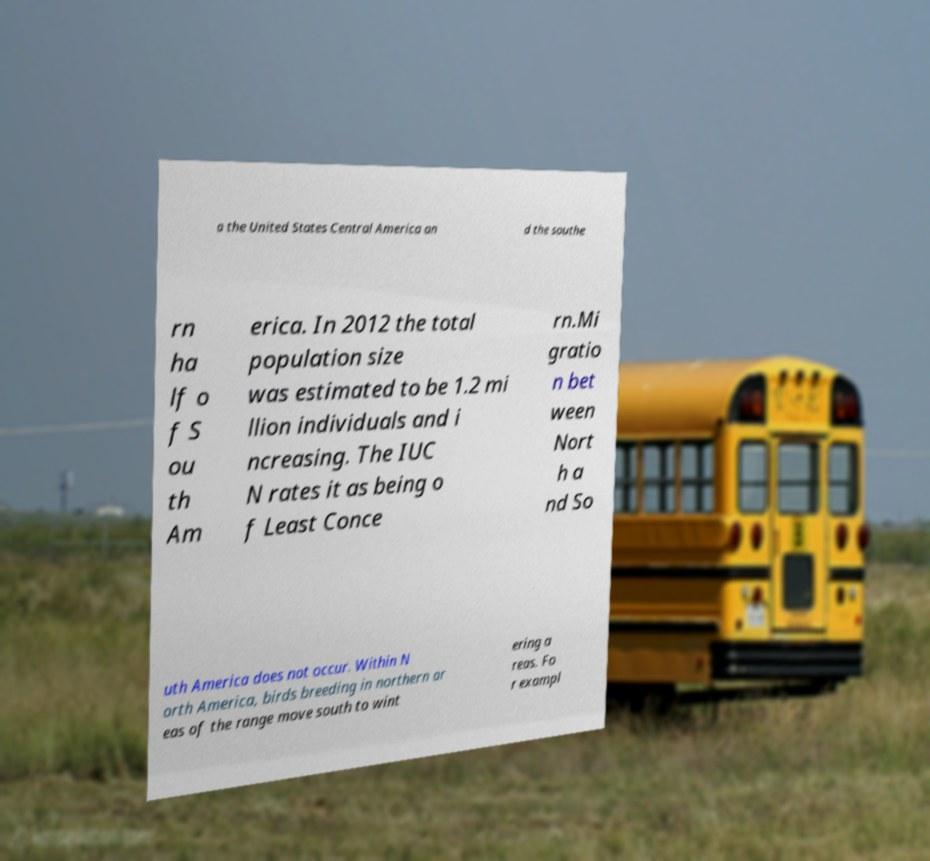There's text embedded in this image that I need extracted. Can you transcribe it verbatim? a the United States Central America an d the southe rn ha lf o f S ou th Am erica. In 2012 the total population size was estimated to be 1.2 mi llion individuals and i ncreasing. The IUC N rates it as being o f Least Conce rn.Mi gratio n bet ween Nort h a nd So uth America does not occur. Within N orth America, birds breeding in northern ar eas of the range move south to wint ering a reas. Fo r exampl 